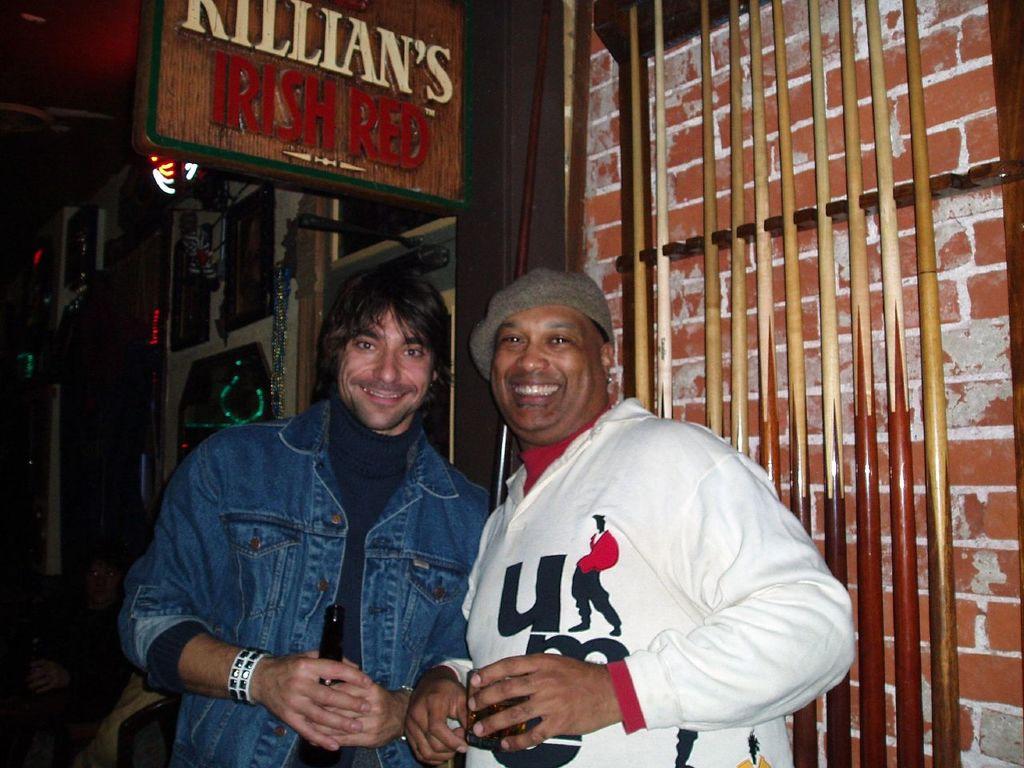Who makes irish red?
Give a very brief answer. Killian's. What letter is on the white shirt?
Give a very brief answer. U. 